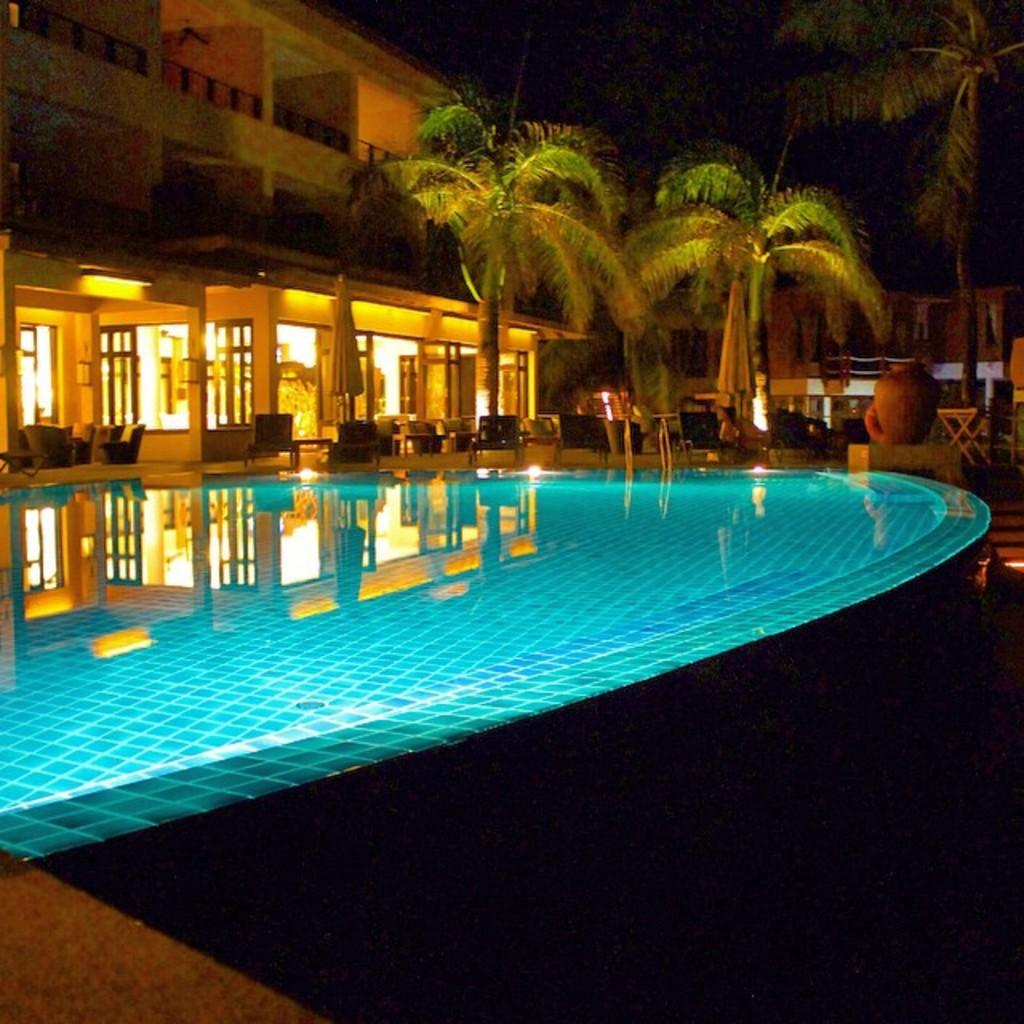What type of surface can be seen in the image? There is a path in the image. What natural element is present in the image? There is water in the image. What object can be seen in the image that is typically used for cooking or storage? There is a pot in the image. What type of furniture is visible in the image? There are chairs in the image. What type of vegetation is present in the image? There are trees in the image. What type of man-made structures are visible in the image? There are buildings in the image. What architectural feature can be seen in the buildings in the image? There are windows in the image. What other objects are present in the image? There are some objects in the image. How would you describe the lighting in the image? The background of the image is dark. How many pigs are playing with a seed in the image? There are no pigs or seeds present in the image. What type of vacation is being depicted in the image? The image does not depict a vacation; it contains a path, water, a pot, chairs, trees, buildings, windows, and some objects. 